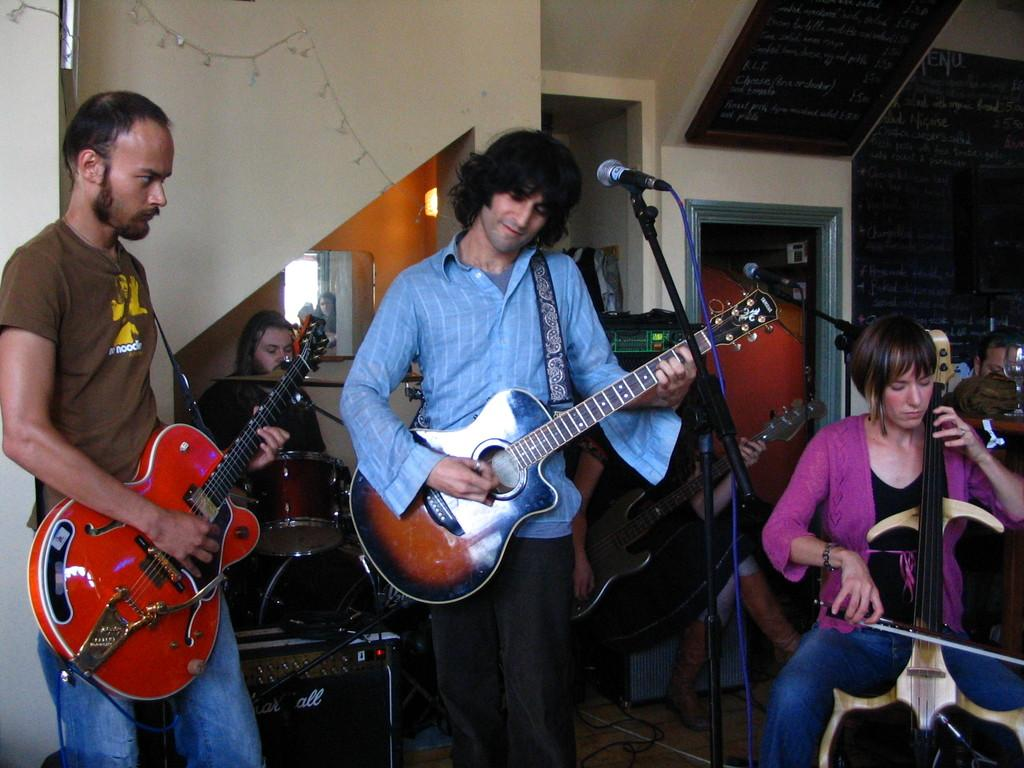What is the main activity being performed by the person in the image? There is a person playing guitar in the image. Can you describe the clothing of the person playing guitar? The person playing guitar is wearing brown, blue, and black. What other musical instruments are being played in the image? There is a person playing violin and a person playing drums. Where is the person playing violin located in the image? The person playing violin is in the right corner of the image. How far away is the person playing drums from the person playing guitar? The person playing drums is in the background of the image, so they are farther away from the person playing guitar. How many goldfish are swimming in the bowl on the table in the image? There is no bowl of goldfish present in the image. What type of fruit is being used as a drumstick in the image? There is no fruit being used as a drumstick in the image. 